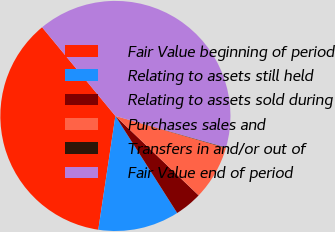<chart> <loc_0><loc_0><loc_500><loc_500><pie_chart><fcel>Fair Value beginning of period<fcel>Relating to assets still held<fcel>Relating to assets sold during<fcel>Purchases sales and<fcel>Transfers in and/or out of<fcel>Fair Value end of period<nl><fcel>36.63%<fcel>11.4%<fcel>3.85%<fcel>7.63%<fcel>0.08%<fcel>40.4%<nl></chart> 